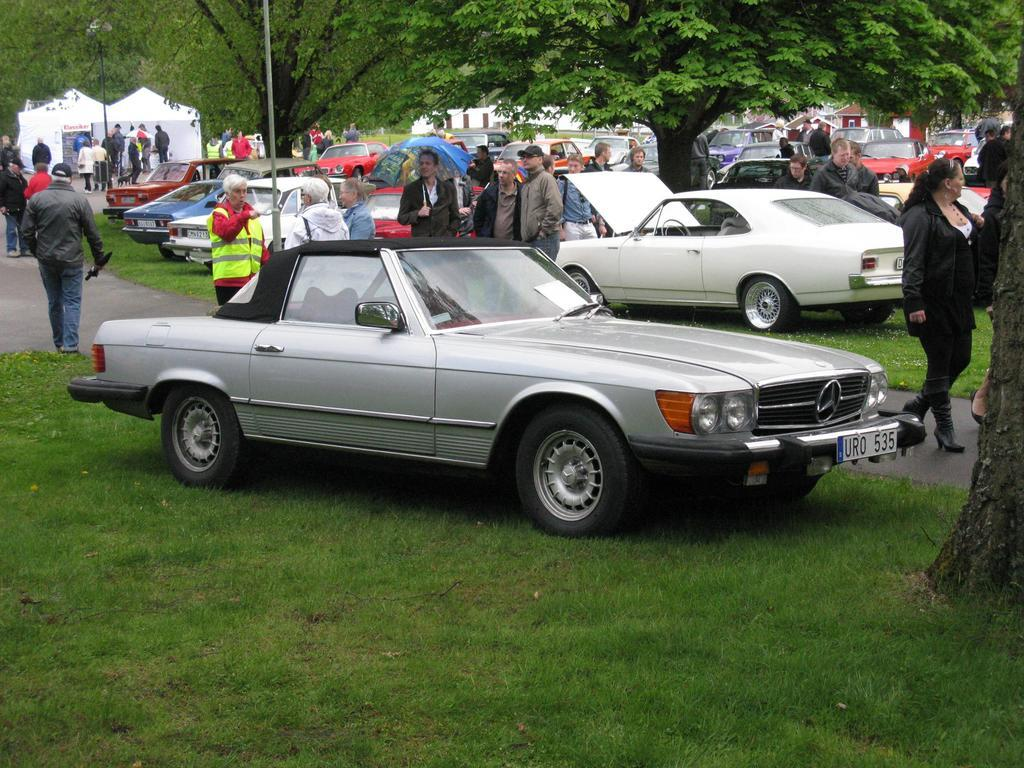What can be seen on the road in the image? There are cars parked on the road in the image. What is happening in the background of the image? There are people standing and walking on the path in the background. What objects can be seen in the background of the image? There are poles, trees, tents, and buildings visible in the background. Can you tell me how many snakes are slithering around the parked cars in the image? There are no snakes present in the image; it features parked cars, people, and various background elements. What type of snails can be seen crawling on the tents in the image? There are no snails present in the image; it features tents, trees, and other background elements. 